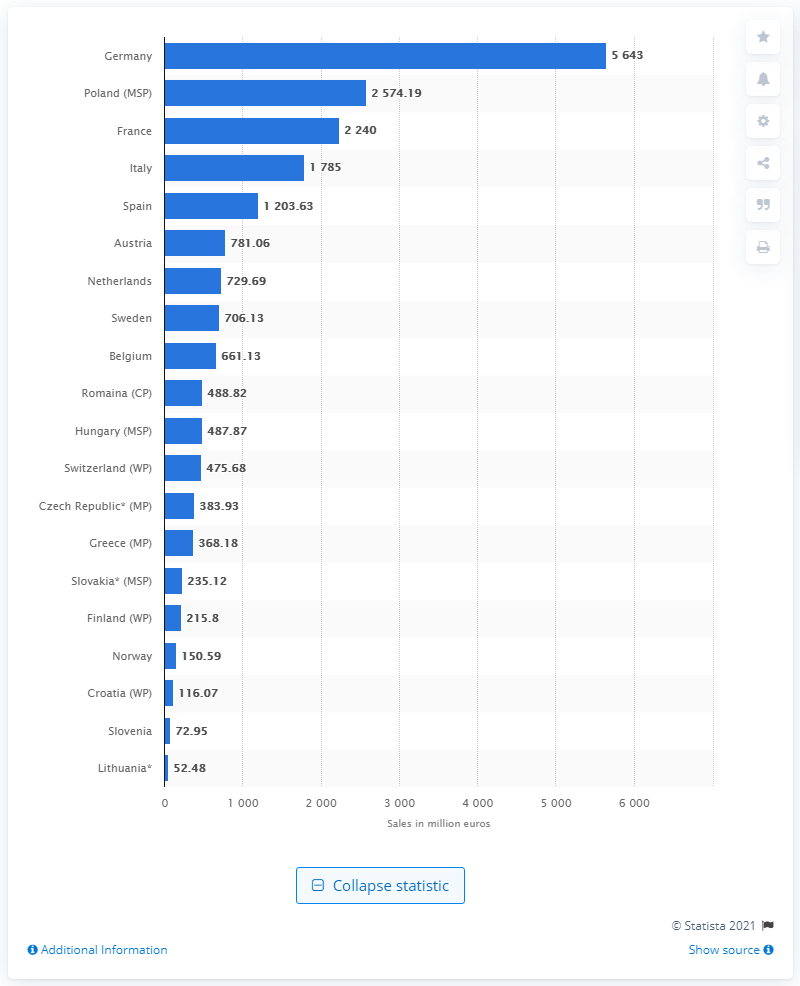Identify some key points in this picture. In 2016, the self-medication sales in Poland were 2574.19 units. In 2016, Germany was the country with the highest sales of self-medication products. In 2017, Lithuania's market share was 52.48%. 